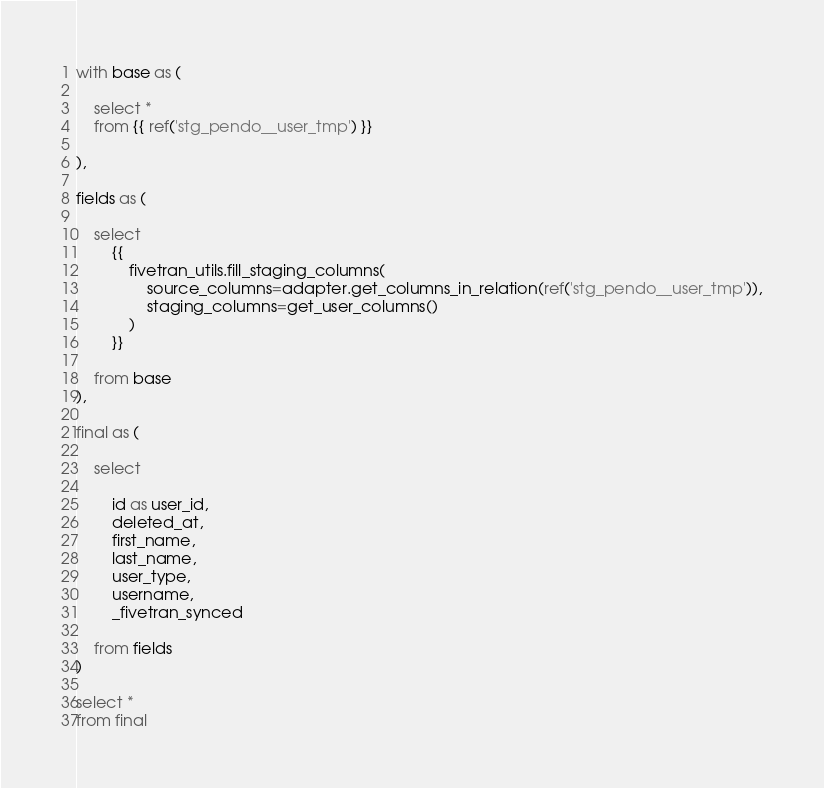Convert code to text. <code><loc_0><loc_0><loc_500><loc_500><_SQL_>
with base as (

    select * 
    from {{ ref('stg_pendo__user_tmp') }}

),

fields as (

    select
        {{
            fivetran_utils.fill_staging_columns(
                source_columns=adapter.get_columns_in_relation(ref('stg_pendo__user_tmp')),
                staging_columns=get_user_columns()
            )
        }}
        
    from base
),

final as (
    
    select 

        id as user_id,
        deleted_at,
        first_name,
        last_name,
        user_type,
        username,
        _fivetran_synced

    from fields
)

select * 
from final
</code> 